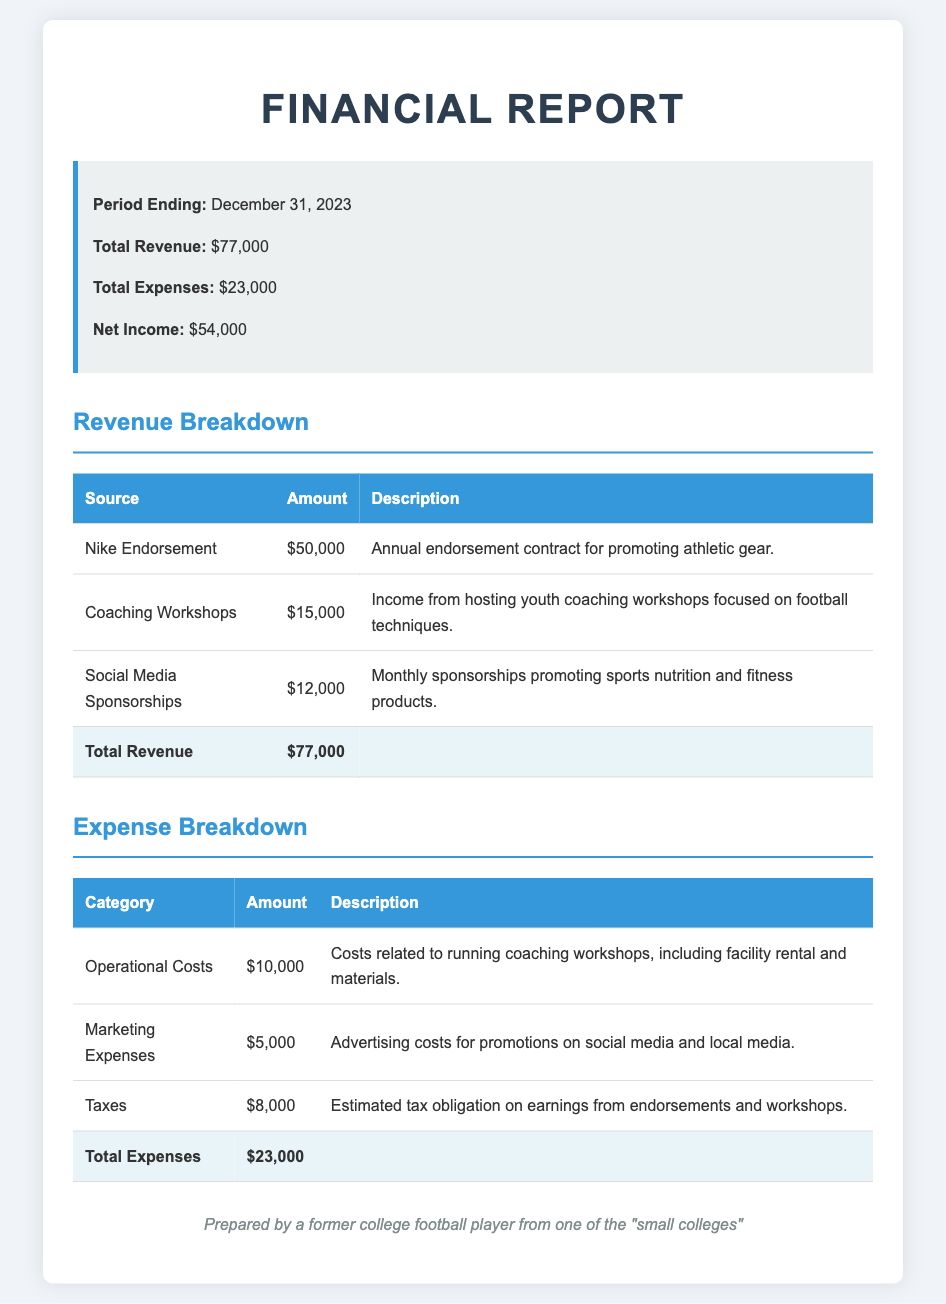What is the total revenue? The total revenue is shown in the summary section of the report, which states that the total revenue is $77,000.
Answer: $77,000 What was the net income for the period? The net income is calculated by subtracting total expenses from total revenue, which is $77,000 - $23,000.
Answer: $54,000 How much did the Nike endorsement generate? The Nike endorsement is listed in the revenue breakdown with an amount of $50,000.
Answer: $50,000 What category had the highest expenses? By reviewing the expense breakdown, the highest expense category is "Taxes" with an amount of $8,000.
Answer: Taxes What is the income from coaching workshops? The income generated specifically from hosting coaching workshops is stated to be $15,000 in the revenue section.
Answer: $15,000 What was the total amount for operational costs? Operational costs are detailed in the expense breakdown, which indicates they amounted to $10,000.
Answer: $10,000 How many sources of revenue are listed? The revenue breakdown includes three distinct sources of revenue, namely Nike endorsement, Coaching Workshops, and Social Media Sponsorships.
Answer: Three What is the total amount spent on marketing expenses? Marketing expenses are outlined in the expense section with a total of $5,000.
Answer: $5,000 What is the period ending date for this financial report? The summary section clearly states that the period ending date is December 31, 2023.
Answer: December 31, 2023 